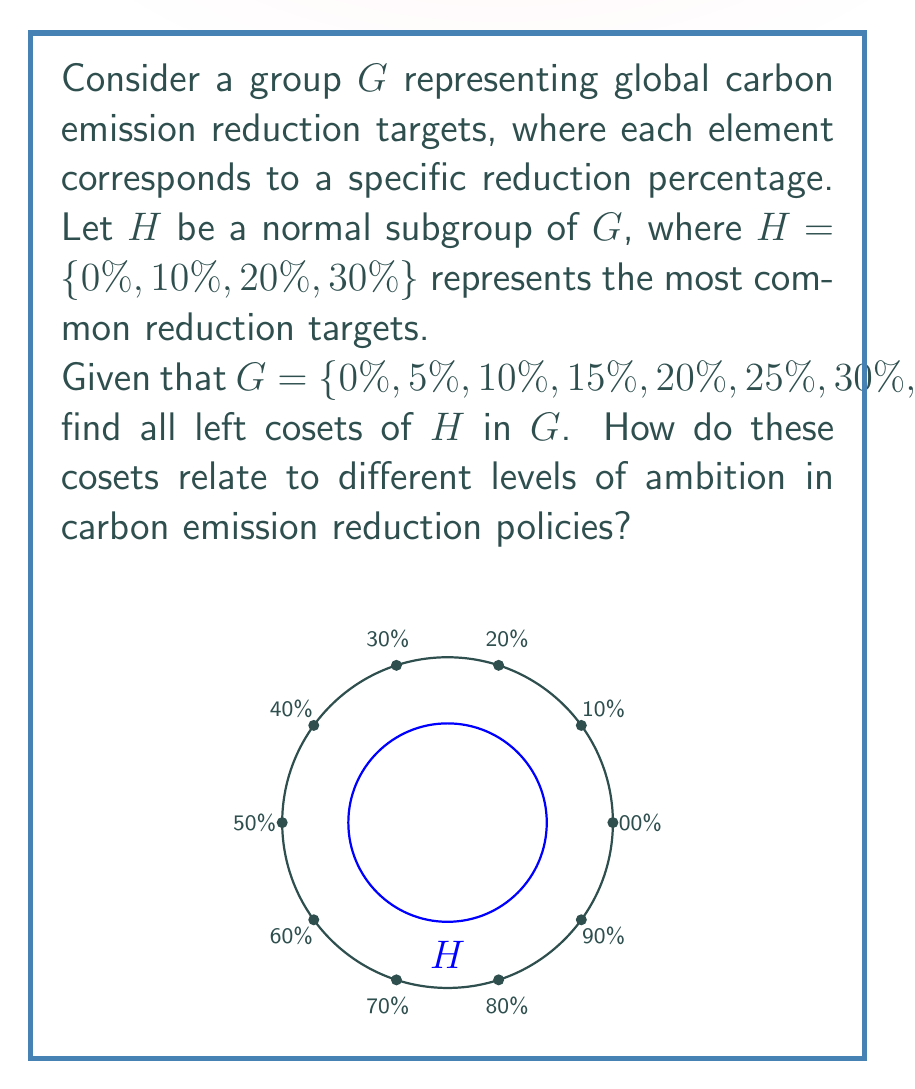What is the answer to this math problem? To find the left cosets of $H$ in $G$, we need to follow these steps:

1) Recall that for a subgroup $H$ of $G$, the left coset of $H$ with respect to an element $a \in G$ is defined as $aH = \{ah : h \in H\}$.

2) Since $H$ is normal in $G$, left cosets are equal to right cosets.

3) We need to compute $aH$ for each $a \in G$:

   For $a = 0\%$: $0\%H = \{0\%, 10\%, 20\%, 30\%\} = H$
   For $a = 5\%$: $5\%H = \{5\%, 15\%, 25\%, 35\%\}$
   For $a = 10\%$: $10\%H = \{10\%, 20\%, 30\%, 40\%\} = H$
   For $a = 15\%$: $15\%H = \{15\%, 25\%, 35\%, 45\%\}$
   For $a = 20\%$: $20\%H = \{20\%, 30\%, 40\%, 0\%\} = H$
   For $a = 25\%$: $25\%H = \{25\%, 35\%, 45\%, 5\%\} = 5\%H$
   For $a = 30\%$: $30\%H = \{30\%, 40\%, 0\%, 10\%\} = H$
   For $a = 35\%$: $35\%H = \{35\%, 45\%, 5\%, 15\%\} = 5\%H$
   For $a = 40\%$: $40\%H = \{40\%, 0\%, 10\%, 20\%\} = H$
   For $a = 45\%$: $45\%H = \{45\%, 5\%, 15\%, 25\%\} = 5\%H$

4) We can see that there are only two distinct cosets:
   $H = \{0\%, 10\%, 20\%, 30\%\}$
   $5\%H = \{5\%, 15\%, 25\%, 35\%\}$

5) The index of $H$ in $G$ is $[G:H] = |G|/|H| = 10/4 = 2.5 = 2$, which confirms our finding of two distinct cosets.

In terms of environmental policy, these cosets represent two levels of ambition in carbon emission reduction targets:
- $H$ represents policies aligned with common reduction targets (multiples of 10%).
- $5\%H$ represents more nuanced policies with intermediate targets, potentially reflecting a more gradual or aggressive approach to emission reduction.
Answer: The left cosets of $H$ in $G$ are $H = \{0\%, 10\%, 20\%, 30\%\}$ and $5\%H = \{5\%, 15\%, 25\%, 35\%\}$. 